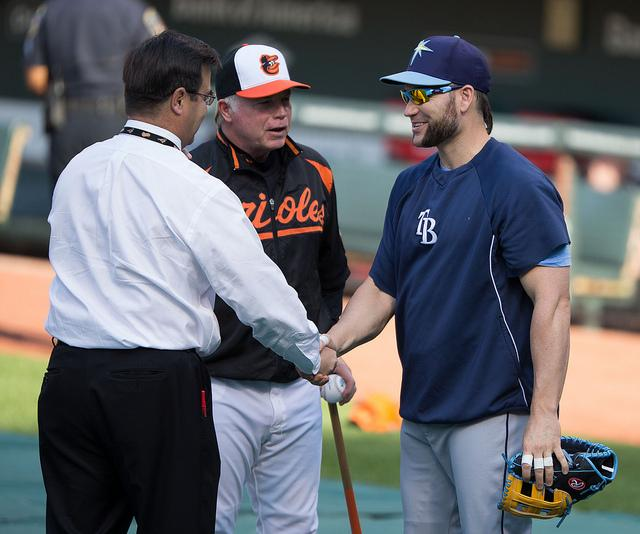Why are the men shaking hands? sportsmanship 